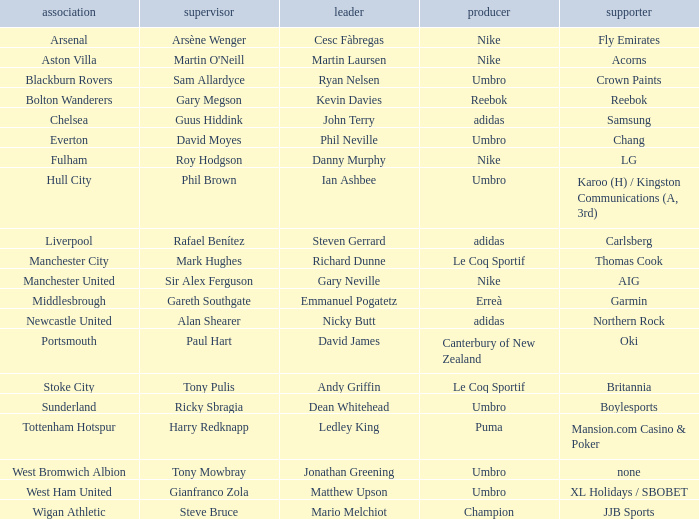Who is the captain of Middlesbrough? Emmanuel Pogatetz. 